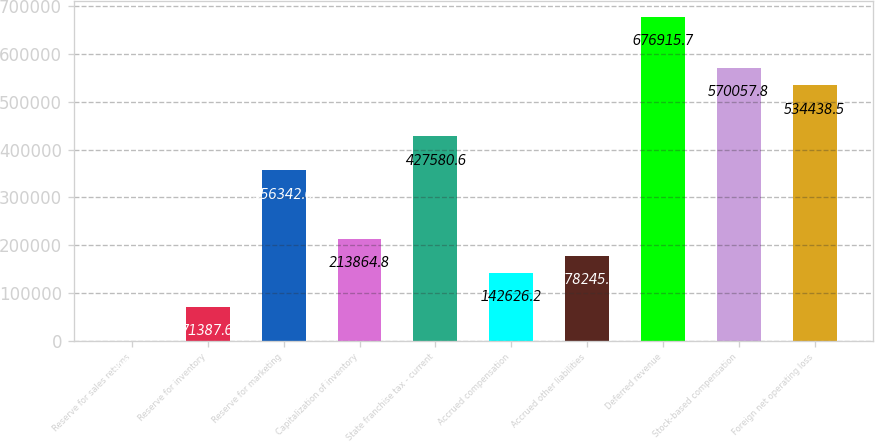<chart> <loc_0><loc_0><loc_500><loc_500><bar_chart><fcel>Reserve for sales returns<fcel>Reserve for inventory<fcel>Reserve for marketing<fcel>Capitalization of inventory<fcel>State franchise tax - current<fcel>Accrued compensation<fcel>Accrued other liabilities<fcel>Deferred revenue<fcel>Stock-based compensation<fcel>Foreign net operating loss<nl><fcel>149<fcel>71387.6<fcel>356342<fcel>213865<fcel>427581<fcel>142626<fcel>178246<fcel>676916<fcel>570058<fcel>534438<nl></chart> 